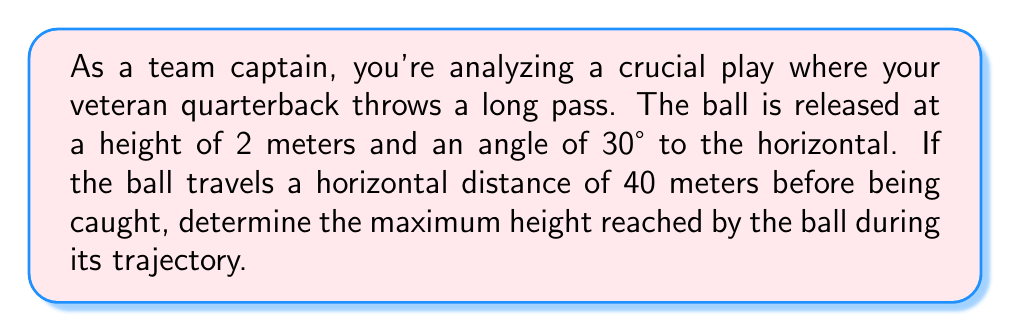Can you solve this math problem? Let's approach this step-by-step using trigonometric functions:

1) The trajectory of the ball follows a parabolic path, which can be described using the equation:

   $$y = \tan(\theta)x - \frac{g}{2v_0^2\cos^2(\theta)}x^2 + h_0$$

   where $y$ is the height, $x$ is the horizontal distance, $\theta$ is the launch angle, $g$ is the acceleration due to gravity (9.8 m/s²), $v_0$ is the initial velocity, and $h_0$ is the initial height.

2) We know $\theta = 30°$, $x = 40$ m when the ball is caught, and $h_0 = 2$ m.

3) To find the maximum height, we need to find the vertex of the parabola. The x-coordinate of the vertex is:

   $$x_{vertex} = \frac{v_0^2\sin(2\theta)}{2g}$$

4) We don't know $v_0$, but we can find it using the fact that the ball travels 40 m horizontally:

   $$40 = v_0\cos(30°)t$$
   $$t = \frac{40}{v_0\cos(30°)}$$

5) We also know that at x = 40 m, y = 2 m (assuming the catch is made at the same height as the release). Using the trajectory equation:

   $$2 = \tan(30°)(40) - \frac{9.8}{2v_0^2\cos^2(30°)}(40)^2 + 2$$

6) Solving this equation:

   $$0 = 40\tan(30°) - \frac{9.8(1600)}{2v_0^2\cos^2(30°)}$$
   $$v_0^2 = \frac{9.8(1600)}{2\cos^2(30°)(40\tan(30°))} \approx 1058.3$$
   $$v_0 \approx 32.53 \text{ m/s}$$

7) Now we can find $x_{vertex}$:

   $$x_{vertex} = \frac{(32.53)^2\sin(60°)}{2(9.8)} \approx 28.17 \text{ m}$$

8) The maximum height occurs at this x-coordinate. Plugging this back into the trajectory equation:

   $$y_{max} = \tan(30°)(28.17) - \frac{9.8}{2(32.53)^2\cos^2(30°)}(28.17)^2 + 2$$

9) Calculating this:

   $$y_{max} \approx 16.26 \text{ m}$$

Therefore, the maximum height reached by the ball is approximately 16.26 meters.
Answer: 16.26 m 